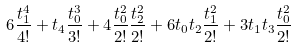<formula> <loc_0><loc_0><loc_500><loc_500>6 \frac { t _ { 1 } ^ { 4 } } { 4 ! } + t _ { 4 } \frac { t _ { 0 } ^ { 3 } } { 3 ! } + 4 \frac { t _ { 0 } ^ { 2 } } { 2 ! } \frac { t _ { 2 } ^ { 2 } } { 2 ! } + 6 t _ { 0 } t _ { 2 } \frac { t _ { 1 } ^ { 2 } } { 2 ! } + 3 t _ { 1 } t _ { 3 } \frac { t _ { 0 } ^ { 2 } } { 2 ! }</formula> 